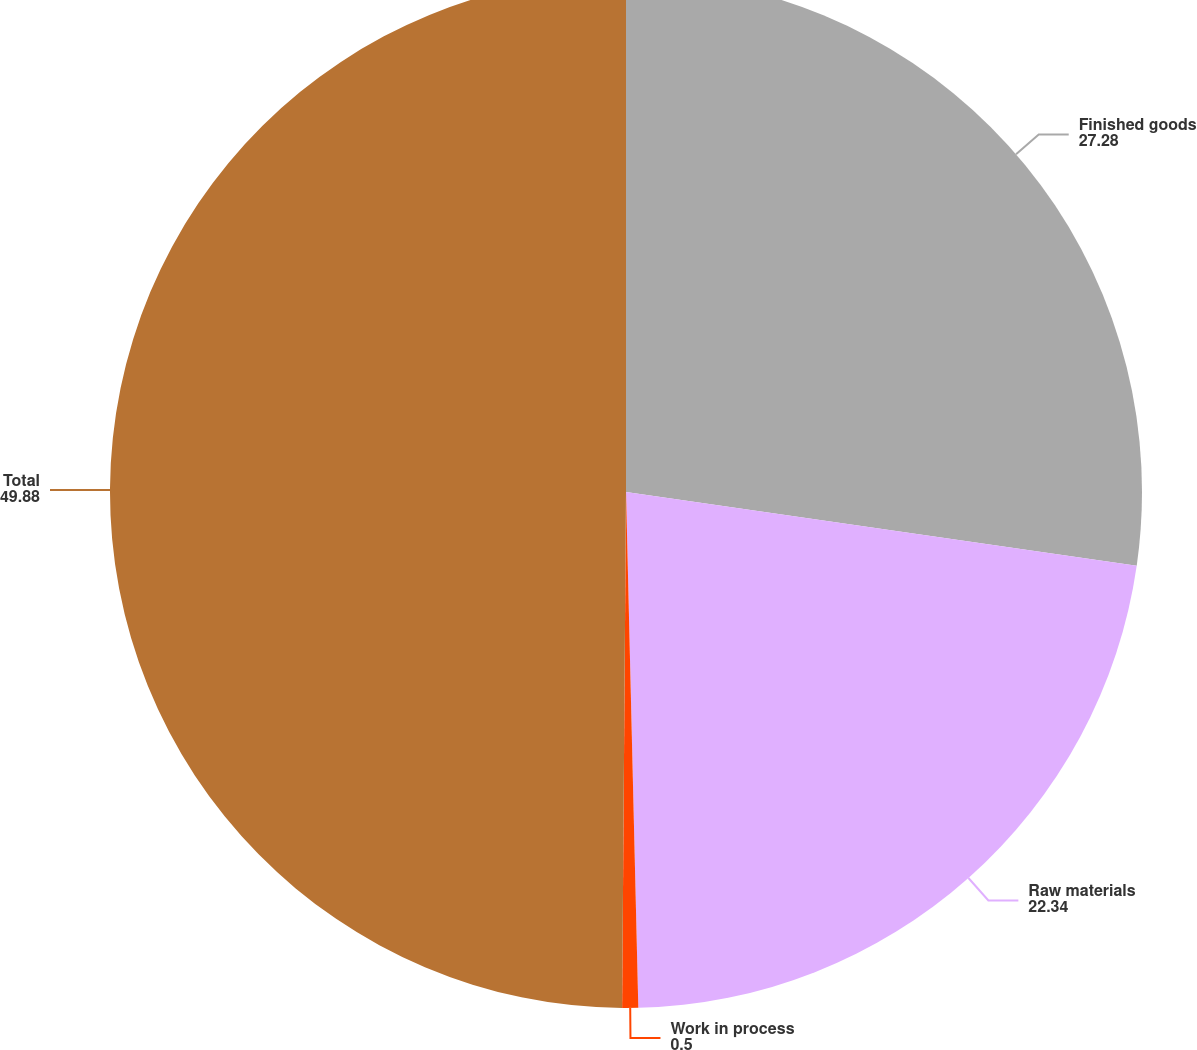Convert chart. <chart><loc_0><loc_0><loc_500><loc_500><pie_chart><fcel>Finished goods<fcel>Raw materials<fcel>Work in process<fcel>Total<nl><fcel>27.28%<fcel>22.34%<fcel>0.5%<fcel>49.88%<nl></chart> 